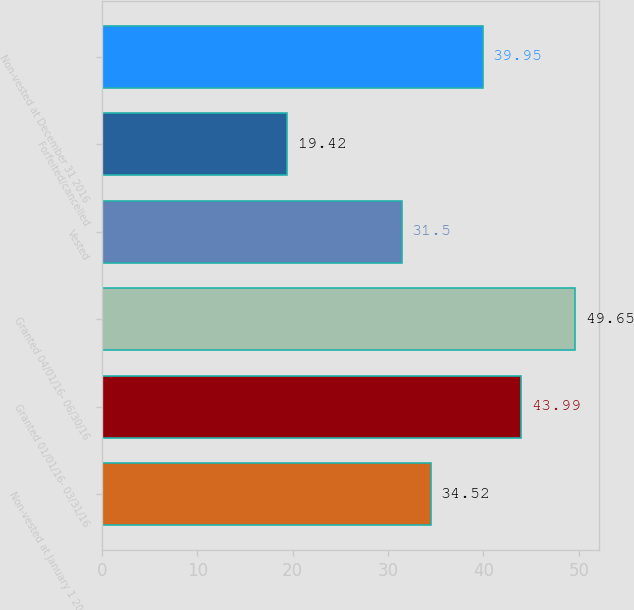Convert chart. <chart><loc_0><loc_0><loc_500><loc_500><bar_chart><fcel>Non-vested at January 1 2016<fcel>Granted 01/01/16- 03/31/16<fcel>Granted 04/01/16- 06/30/16<fcel>Vested<fcel>Forfeited/cancelled<fcel>Non-vested at December 31 2016<nl><fcel>34.52<fcel>43.99<fcel>49.65<fcel>31.5<fcel>19.42<fcel>39.95<nl></chart> 